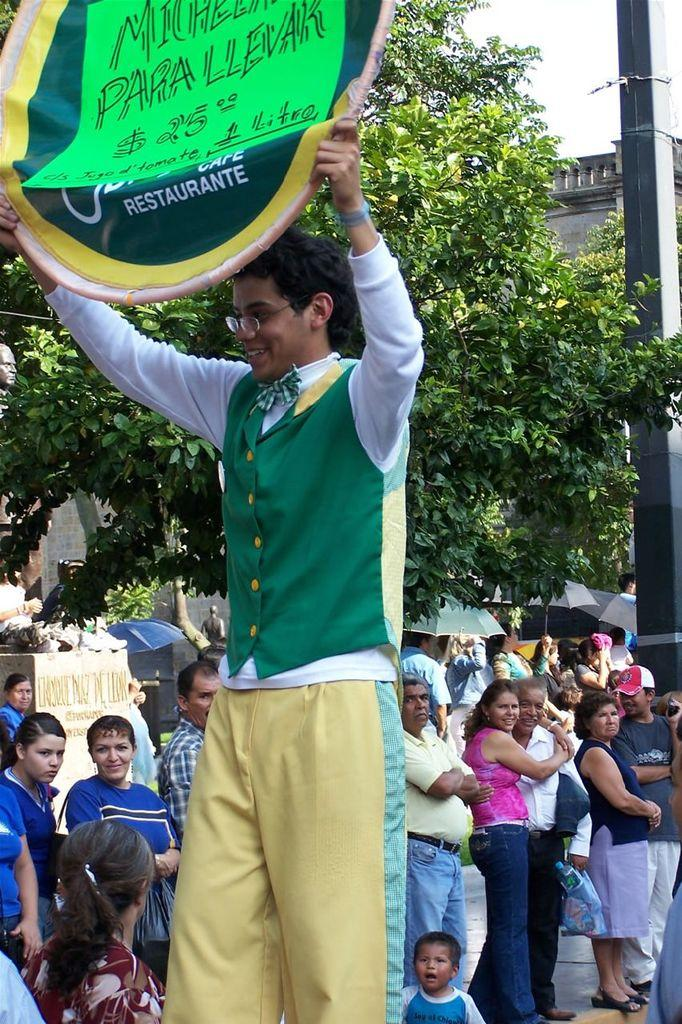What is the main subject in the center of the image? There is a person standing with a board in the center of the image. What can be seen in the background of the image? There are persons, trees, a building, a pole, and the sky visible in the background of the image. What type of writing can be seen on the board held by the person in the image? There is no writing visible on the board held by the person in the image. Can you spot any deer in the image? There are no deer present in the image. 